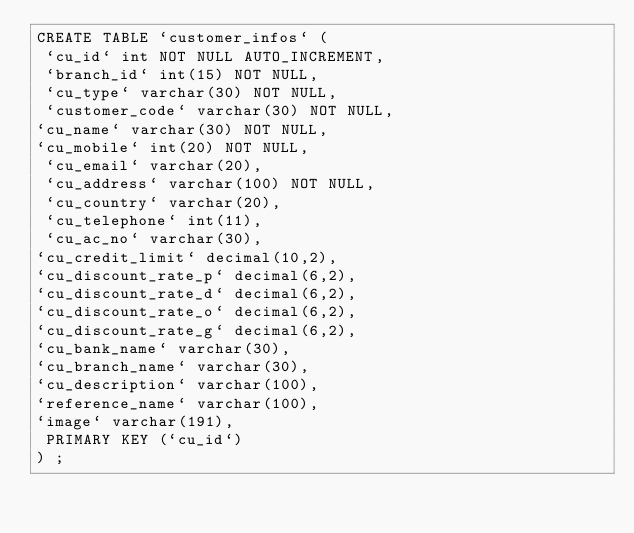Convert code to text. <code><loc_0><loc_0><loc_500><loc_500><_SQL_>CREATE TABLE `customer_infos` (
 `cu_id` int NOT NULL AUTO_INCREMENT,
 `branch_id` int(15) NOT NULL,
 `cu_type` varchar(30) NOT NULL,
 `customer_code` varchar(30) NOT NULL,
`cu_name` varchar(30) NOT NULL,
`cu_mobile` int(20) NOT NULL,
 `cu_email` varchar(20),
 `cu_address` varchar(100) NOT NULL,
 `cu_country` varchar(20),
 `cu_telephone` int(11),
 `cu_ac_no` varchar(30),
`cu_credit_limit` decimal(10,2),
`cu_discount_rate_p` decimal(6,2),
`cu_discount_rate_d` decimal(6,2),
`cu_discount_rate_o` decimal(6,2),
`cu_discount_rate_g` decimal(6,2),
`cu_bank_name` varchar(30),
`cu_branch_name` varchar(30),
`cu_description` varchar(100),
`reference_name` varchar(100),
`image` varchar(191),
 PRIMARY KEY (`cu_id`)
) ;
</code> 